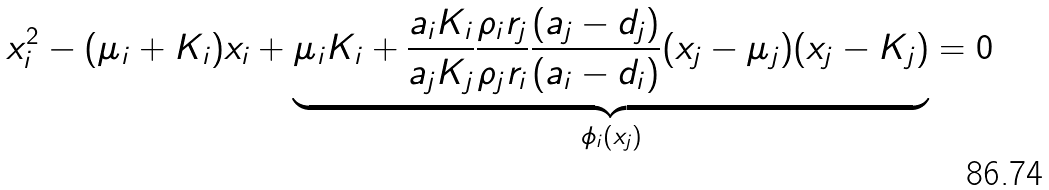<formula> <loc_0><loc_0><loc_500><loc_500>x _ { i } ^ { 2 } - ( \mu _ { i } + K _ { i } ) x _ { i } + \underbrace { \mu _ { i } K _ { i } + \frac { a _ { i } K _ { i } } { a _ { j } K _ { j } } \frac { \rho _ { i } r _ { j } } { \rho _ { j } r _ { i } } \frac { ( a _ { j } - d _ { j } ) } { ( a _ { i } - d _ { i } ) } ( x _ { j } - \mu _ { j } ) ( x _ { j } - K _ { j } ) } _ { \phi _ { i } ( x _ { j } ) } = 0</formula> 